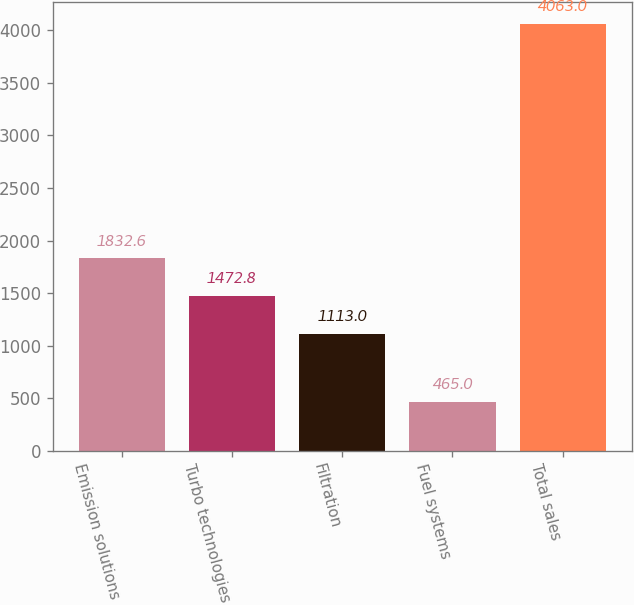Convert chart. <chart><loc_0><loc_0><loc_500><loc_500><bar_chart><fcel>Emission solutions<fcel>Turbo technologies<fcel>Filtration<fcel>Fuel systems<fcel>Total sales<nl><fcel>1832.6<fcel>1472.8<fcel>1113<fcel>465<fcel>4063<nl></chart> 